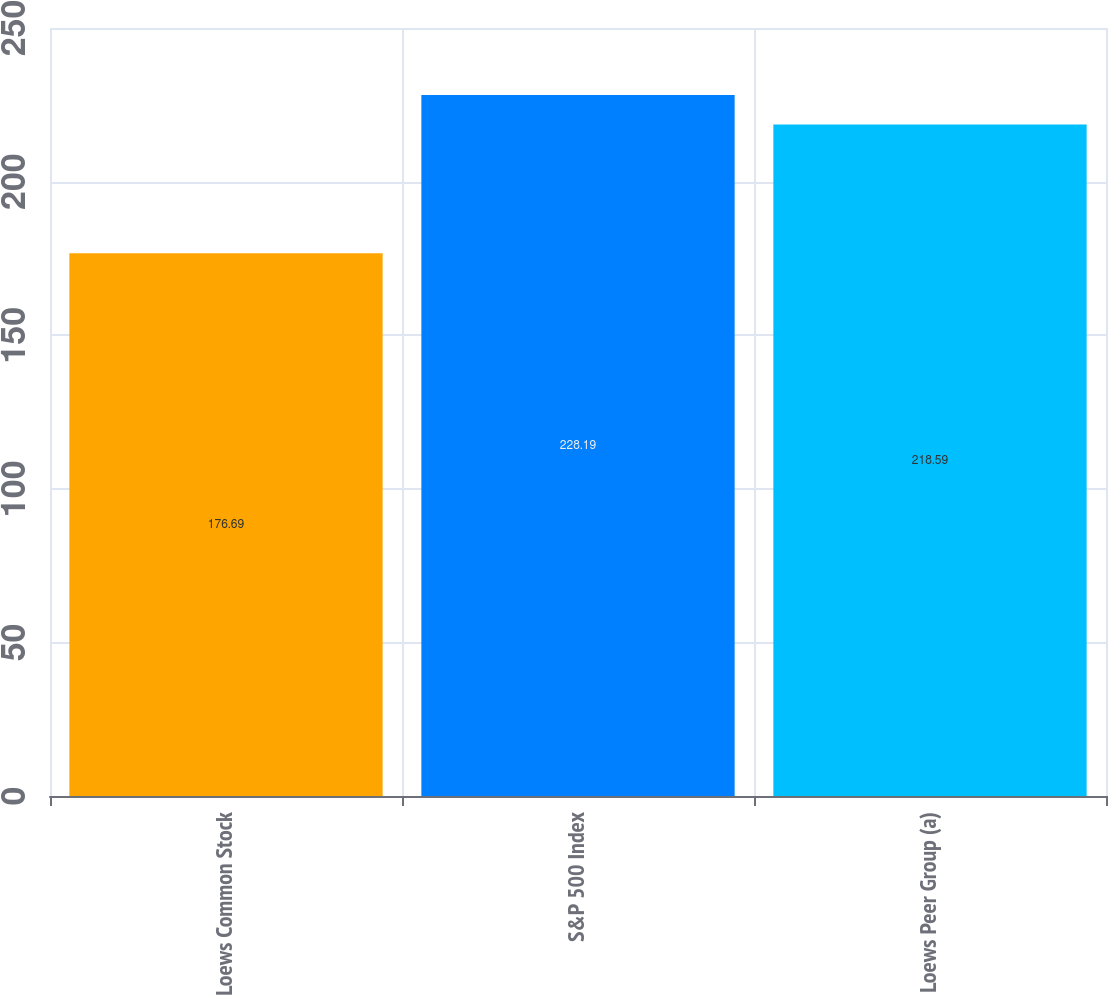Convert chart to OTSL. <chart><loc_0><loc_0><loc_500><loc_500><bar_chart><fcel>Loews Common Stock<fcel>S&P 500 Index<fcel>Loews Peer Group (a)<nl><fcel>176.69<fcel>228.19<fcel>218.59<nl></chart> 